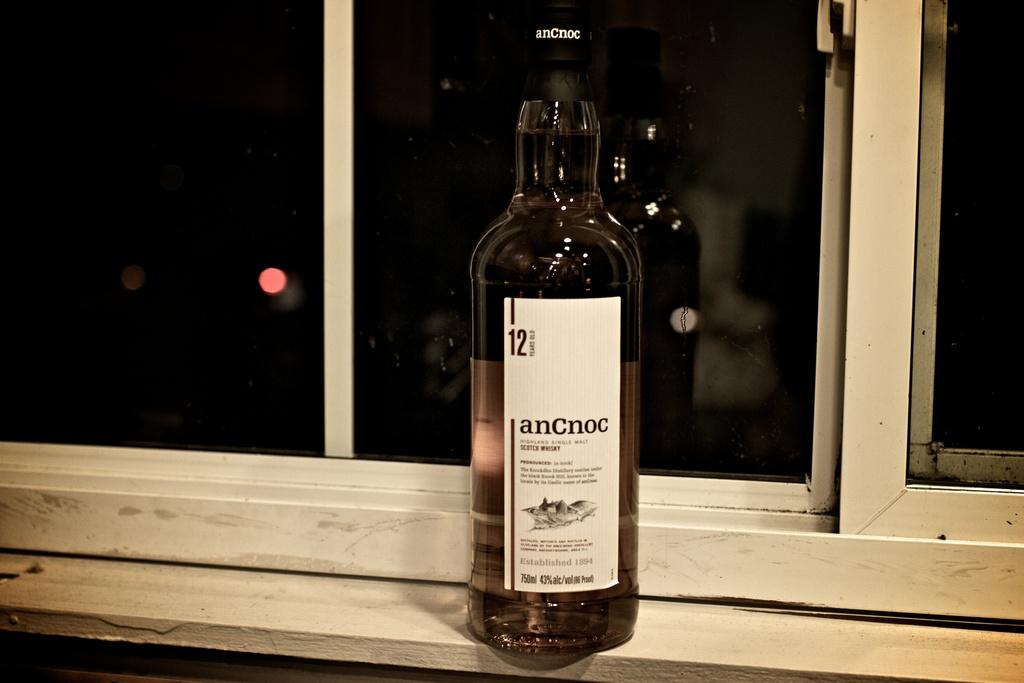What is the main subject in the center of the image? There is a wine bottle in the center of the image. Where is the wine bottle located? The wine bottle is on a table. What can be seen in the background of the image? There is a window visible in the background of the image. What type of flag is being painted on the canvas in the image? There is no canvas or flag present in the image; it features a wine bottle on a table. 